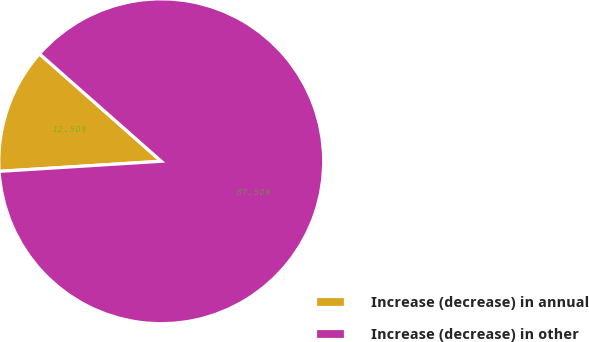Convert chart. <chart><loc_0><loc_0><loc_500><loc_500><pie_chart><fcel>Increase (decrease) in annual<fcel>Increase (decrease) in other<nl><fcel>12.5%<fcel>87.5%<nl></chart> 